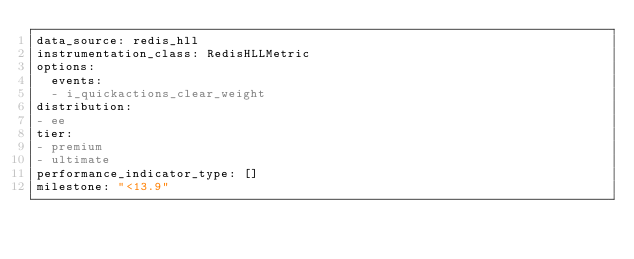Convert code to text. <code><loc_0><loc_0><loc_500><loc_500><_YAML_>data_source: redis_hll
instrumentation_class: RedisHLLMetric
options:
  events:
  - i_quickactions_clear_weight
distribution:
- ee
tier:
- premium
- ultimate
performance_indicator_type: []
milestone: "<13.9"
</code> 